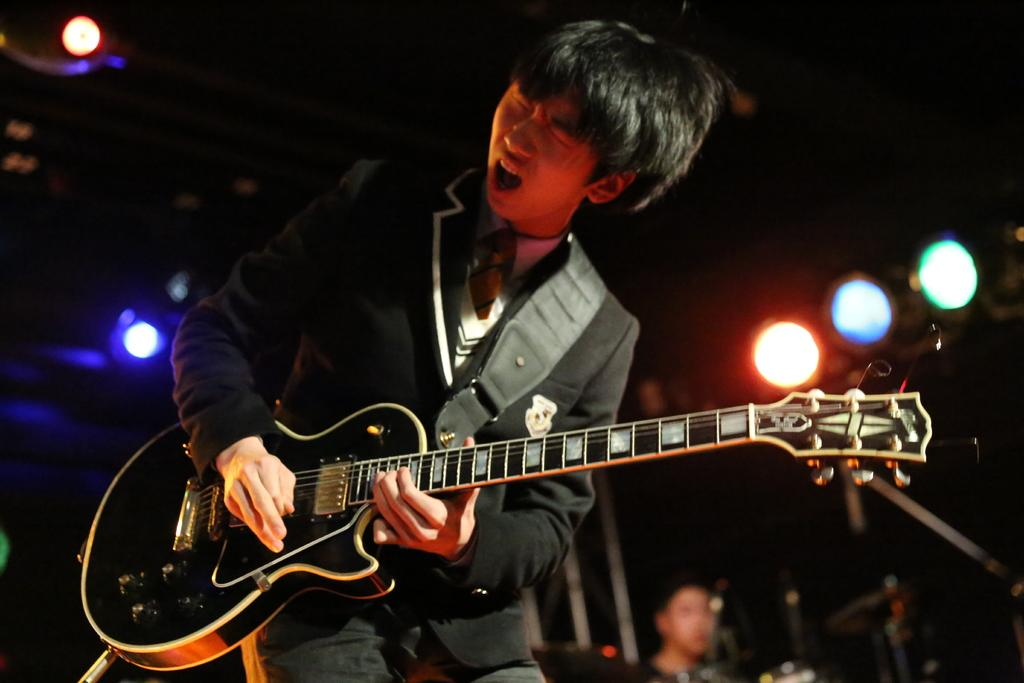What is the person in the image doing? The person is playing the guitar. What type of clothing is the person wearing? The person is wearing a blazer. Can you describe the background of the image? There is another person and lights visible in the background of the image. How many airplanes can be seen at the airport in the image? There is no airport or airplanes present in the image. What type of light is being used by the person in the image? The image does not show any specific type of light being used by the person; it only mentions that there are lights visible in the background. 